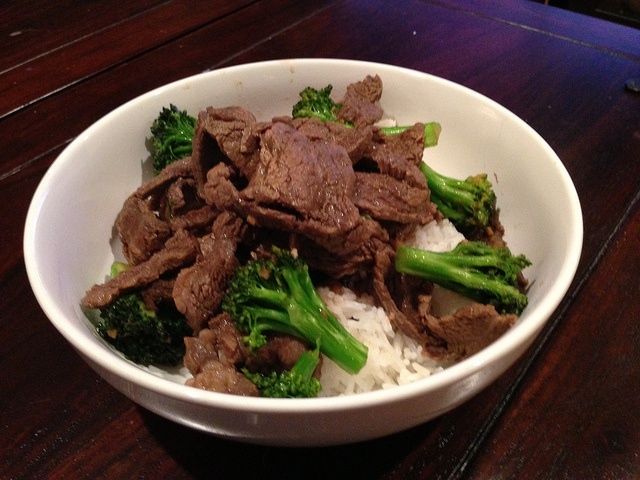Describe the objects in this image and their specific colors. I can see dining table in black, maroon, olive, ivory, and darkgray tones, bowl in black, maroon, olive, and ivory tones, broccoli in black, darkgreen, and olive tones, broccoli in black, darkgreen, and olive tones, and broccoli in black, darkgreen, and darkgray tones in this image. 